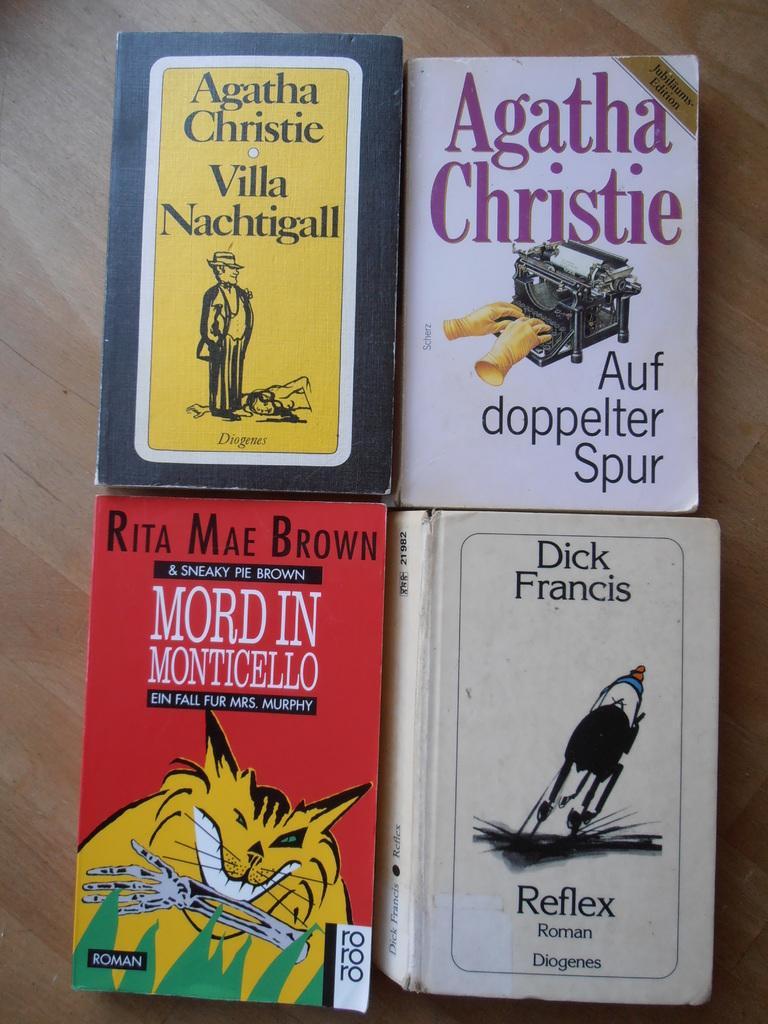In one or two sentences, can you explain what this image depicts? In this image there are books on the table. On the books there are images and some text. Left top there is a book having a picture of a person. Right top there is a book having an image of a machine and gloves. 